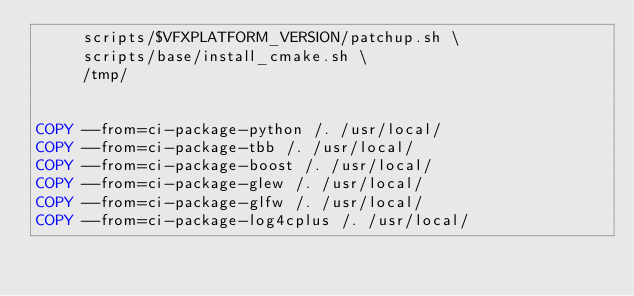<code> <loc_0><loc_0><loc_500><loc_500><_Dockerfile_>     scripts/$VFXPLATFORM_VERSION/patchup.sh \
     scripts/base/install_cmake.sh \
     /tmp/


COPY --from=ci-package-python /. /usr/local/
COPY --from=ci-package-tbb /. /usr/local/
COPY --from=ci-package-boost /. /usr/local/
COPY --from=ci-package-glew /. /usr/local/
COPY --from=ci-package-glfw /. /usr/local/
COPY --from=ci-package-log4cplus /. /usr/local/</code> 